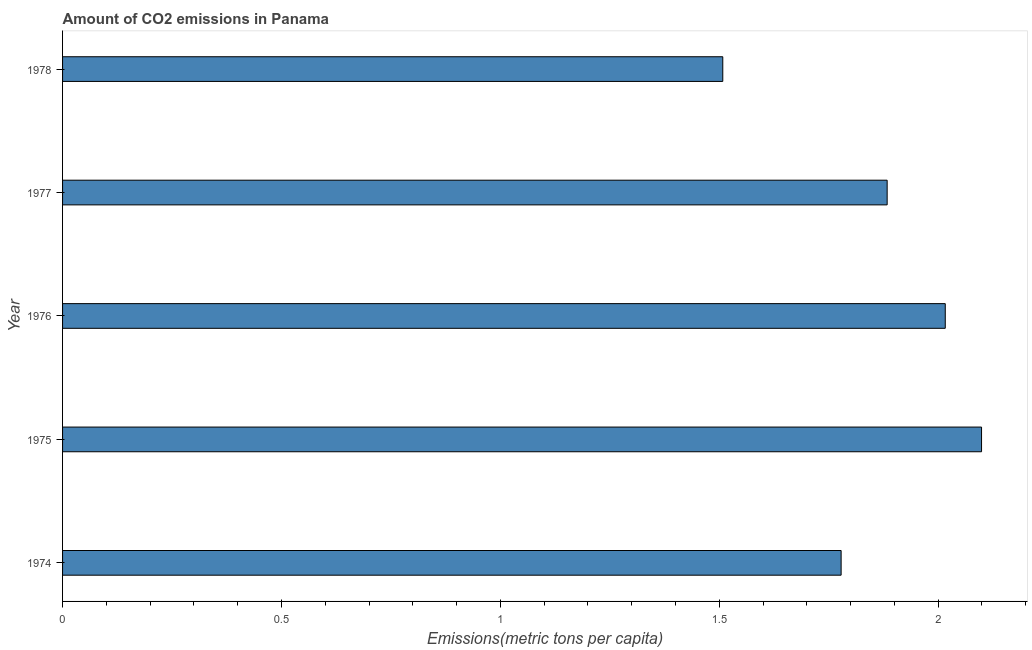Does the graph contain grids?
Provide a succinct answer. No. What is the title of the graph?
Your answer should be very brief. Amount of CO2 emissions in Panama. What is the label or title of the X-axis?
Give a very brief answer. Emissions(metric tons per capita). What is the label or title of the Y-axis?
Keep it short and to the point. Year. What is the amount of co2 emissions in 1974?
Offer a very short reply. 1.78. Across all years, what is the maximum amount of co2 emissions?
Offer a very short reply. 2.1. Across all years, what is the minimum amount of co2 emissions?
Ensure brevity in your answer.  1.51. In which year was the amount of co2 emissions maximum?
Provide a short and direct response. 1975. In which year was the amount of co2 emissions minimum?
Provide a short and direct response. 1978. What is the sum of the amount of co2 emissions?
Make the answer very short. 9.29. What is the difference between the amount of co2 emissions in 1975 and 1976?
Offer a very short reply. 0.08. What is the average amount of co2 emissions per year?
Offer a terse response. 1.86. What is the median amount of co2 emissions?
Offer a very short reply. 1.88. Do a majority of the years between 1977 and 1975 (inclusive) have amount of co2 emissions greater than 0.9 metric tons per capita?
Provide a succinct answer. Yes. What is the ratio of the amount of co2 emissions in 1975 to that in 1977?
Ensure brevity in your answer.  1.11. Is the difference between the amount of co2 emissions in 1974 and 1978 greater than the difference between any two years?
Provide a short and direct response. No. What is the difference between the highest and the second highest amount of co2 emissions?
Your answer should be compact. 0.08. What is the difference between the highest and the lowest amount of co2 emissions?
Provide a short and direct response. 0.59. In how many years, is the amount of co2 emissions greater than the average amount of co2 emissions taken over all years?
Your response must be concise. 3. Are all the bars in the graph horizontal?
Ensure brevity in your answer.  Yes. Are the values on the major ticks of X-axis written in scientific E-notation?
Offer a very short reply. No. What is the Emissions(metric tons per capita) in 1974?
Ensure brevity in your answer.  1.78. What is the Emissions(metric tons per capita) in 1975?
Keep it short and to the point. 2.1. What is the Emissions(metric tons per capita) of 1976?
Keep it short and to the point. 2.02. What is the Emissions(metric tons per capita) in 1977?
Offer a very short reply. 1.88. What is the Emissions(metric tons per capita) in 1978?
Provide a short and direct response. 1.51. What is the difference between the Emissions(metric tons per capita) in 1974 and 1975?
Give a very brief answer. -0.32. What is the difference between the Emissions(metric tons per capita) in 1974 and 1976?
Keep it short and to the point. -0.24. What is the difference between the Emissions(metric tons per capita) in 1974 and 1977?
Your response must be concise. -0.11. What is the difference between the Emissions(metric tons per capita) in 1974 and 1978?
Your answer should be very brief. 0.27. What is the difference between the Emissions(metric tons per capita) in 1975 and 1976?
Keep it short and to the point. 0.08. What is the difference between the Emissions(metric tons per capita) in 1975 and 1977?
Keep it short and to the point. 0.22. What is the difference between the Emissions(metric tons per capita) in 1975 and 1978?
Your answer should be compact. 0.59. What is the difference between the Emissions(metric tons per capita) in 1976 and 1977?
Your answer should be compact. 0.13. What is the difference between the Emissions(metric tons per capita) in 1976 and 1978?
Offer a terse response. 0.51. What is the difference between the Emissions(metric tons per capita) in 1977 and 1978?
Provide a short and direct response. 0.38. What is the ratio of the Emissions(metric tons per capita) in 1974 to that in 1975?
Ensure brevity in your answer.  0.85. What is the ratio of the Emissions(metric tons per capita) in 1974 to that in 1976?
Make the answer very short. 0.88. What is the ratio of the Emissions(metric tons per capita) in 1974 to that in 1977?
Offer a very short reply. 0.94. What is the ratio of the Emissions(metric tons per capita) in 1974 to that in 1978?
Provide a succinct answer. 1.18. What is the ratio of the Emissions(metric tons per capita) in 1975 to that in 1976?
Provide a short and direct response. 1.04. What is the ratio of the Emissions(metric tons per capita) in 1975 to that in 1977?
Your answer should be very brief. 1.11. What is the ratio of the Emissions(metric tons per capita) in 1975 to that in 1978?
Provide a short and direct response. 1.39. What is the ratio of the Emissions(metric tons per capita) in 1976 to that in 1977?
Ensure brevity in your answer.  1.07. What is the ratio of the Emissions(metric tons per capita) in 1976 to that in 1978?
Your response must be concise. 1.34. What is the ratio of the Emissions(metric tons per capita) in 1977 to that in 1978?
Give a very brief answer. 1.25. 